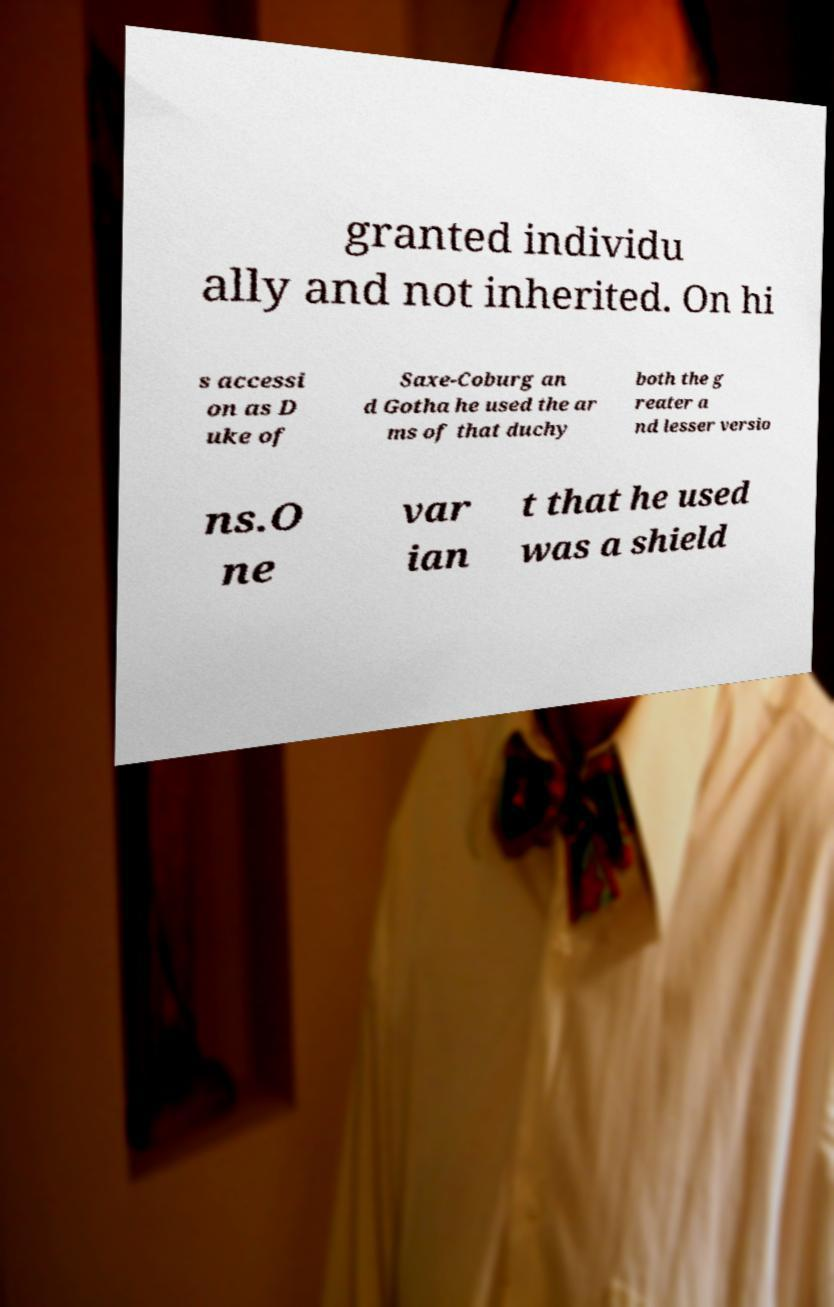Please read and relay the text visible in this image. What does it say? granted individu ally and not inherited. On hi s accessi on as D uke of Saxe-Coburg an d Gotha he used the ar ms of that duchy both the g reater a nd lesser versio ns.O ne var ian t that he used was a shield 